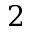<formula> <loc_0><loc_0><loc_500><loc_500>2</formula> 